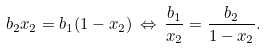Convert formula to latex. <formula><loc_0><loc_0><loc_500><loc_500>b _ { 2 } x _ { 2 } = b _ { 1 } ( 1 - x _ { 2 } ) \, \Leftrightarrow \, \frac { b _ { 1 } } { x _ { 2 } } = \frac { b _ { 2 } } { 1 - x _ { 2 } } .</formula> 